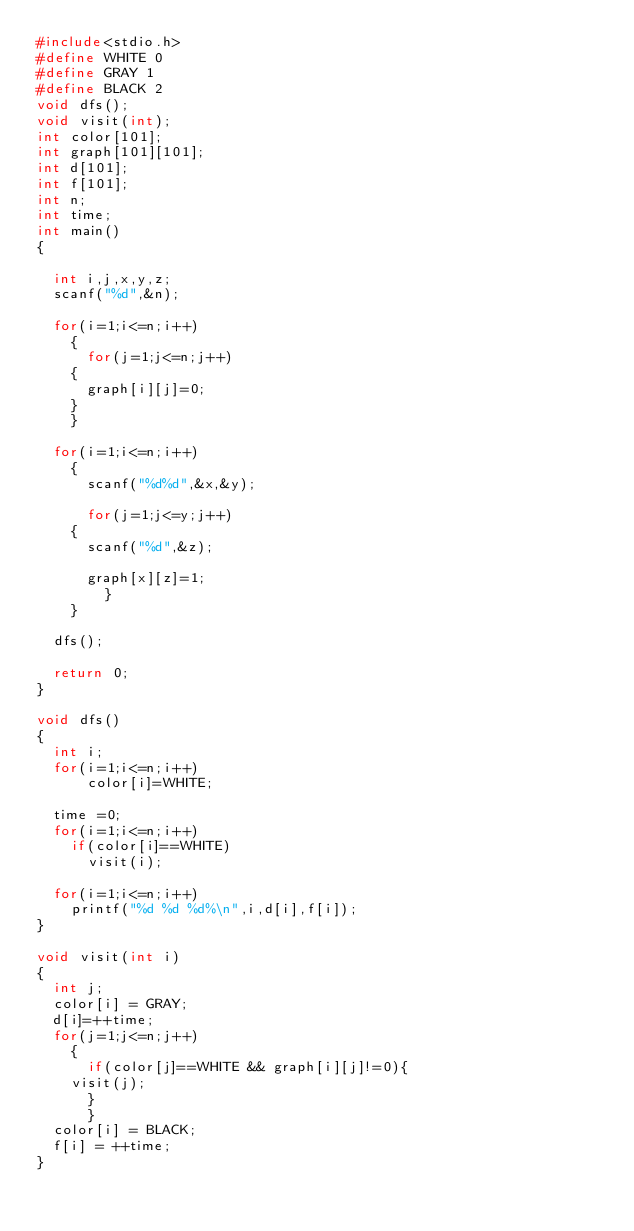Convert code to text. <code><loc_0><loc_0><loc_500><loc_500><_C_>#include<stdio.h>
#define WHITE 0
#define GRAY 1
#define BLACK 2
void dfs();
void visit(int);
int color[101];
int graph[101][101];
int d[101];
int f[101];
int n;
int time;
int main()
{
  
  int i,j,x,y,z;
  scanf("%d",&n);

  for(i=1;i<=n;i++)
    {
      for(j=1;j<=n;j++)
	{
	  graph[i][j]=0;
	}
    }

  for(i=1;i<=n;i++)
    {
      scanf("%d%d",&x,&y);
      
      for(j=1;j<=y;j++)
	{
	  scanf("%d",&z);
	  
	  graph[x][z]=1;
	    }
    }

  dfs();

  return 0;
}

void dfs()
{
  int i;
  for(i=1;i<=n;i++)
      color[i]=WHITE;

  time =0;
  for(i=1;i<=n;i++)
    if(color[i]==WHITE)
      visit(i);

  for(i=1;i<=n;i++)
    printf("%d %d %d%\n",i,d[i],f[i]);
}

void visit(int i)
{
  int j;
  color[i] = GRAY;
  d[i]=++time;
  for(j=1;j<=n;j++)
    {
      if(color[j]==WHITE && graph[i][j]!=0){
	visit(j);
      }
	  }
  color[i] = BLACK;
  f[i] = ++time;
}</code> 